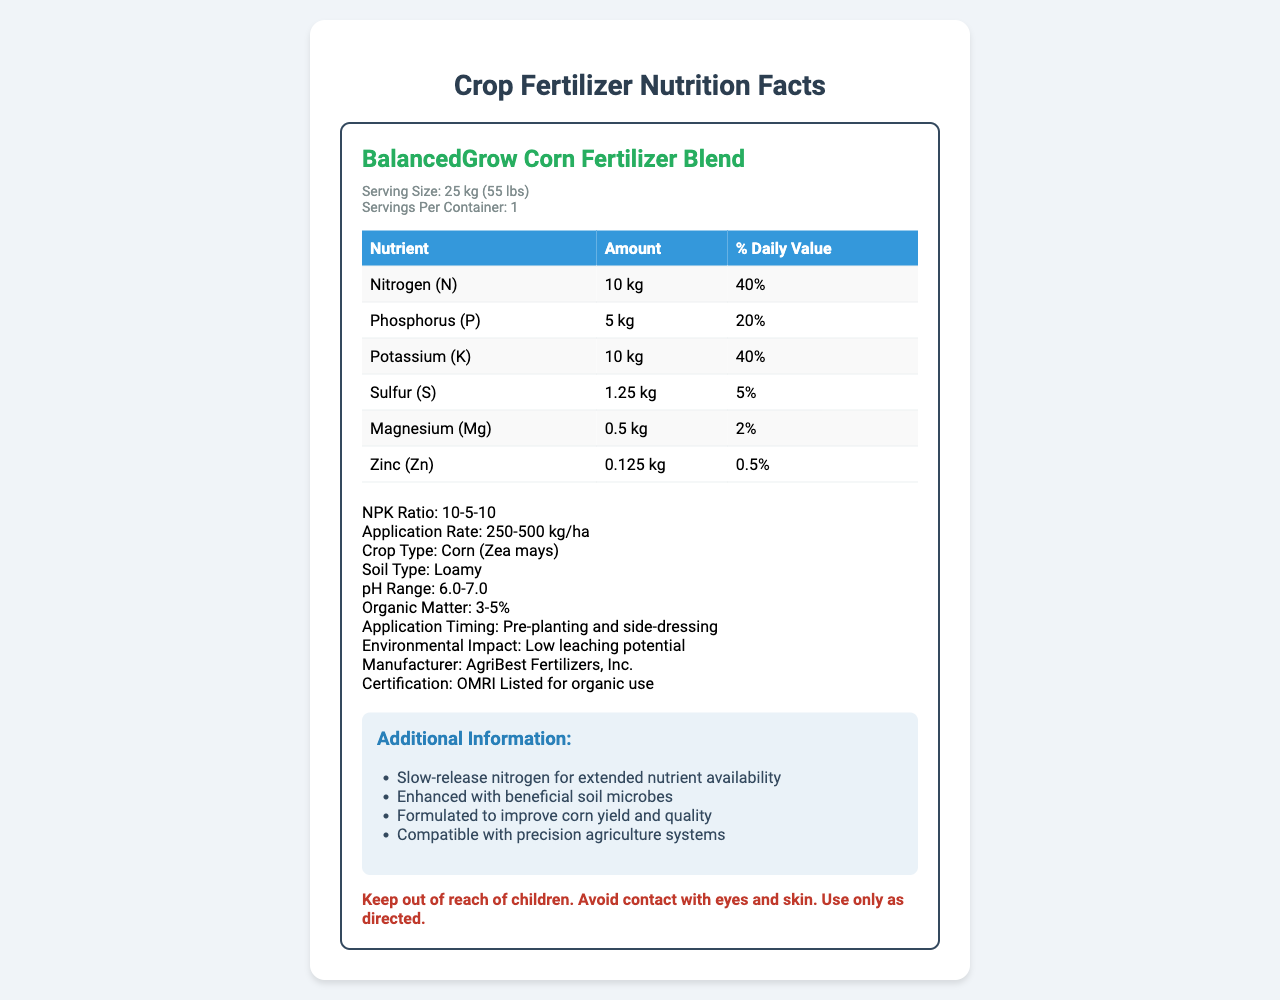what is the NPK ratio of the BalancedGrow Corn Fertilizer Blend? The document clearly states the NPK ratio as "10-5-10."
Answer: 10-5-10 what is the recommended application rate? The document specifies that the application rate is "250-500 kg/ha."
Answer: 250-500 kg/ha what soil type is this fertilizer blend best suited for? The document mentions that the suitable soil type is "Loamy."
Answer: Loamy how much Phosphorus (P) does one serving contain? The table lists the amount of Phosphorus as "5 kg."
Answer: 5 kg what is the percentage daily value of Sulfur (S) provided by this fertilizer? According to the table, Sulfur has a daily value percentage of "5%."
Answer: 5% what nutrient has the lowest percentage daily value in this fertilizer blend? A. Nitrogen (N) B. Phosphorus (P) C. Magnesium (Mg) D. Zinc (Zn) The table shows Zinc (Zn) with a percentage daily value of "0.5%", which is the lowest among the listed nutrients.
Answer: D. Zinc (Zn) who is the manufacturer of this fertilizer? A. AgriBest Fertilizers, Inc. B. GreenGrow Fertilizers Co. C. CropCare Manufacturers The document states that the manufacturer is "AgriBest Fertilizers, Inc."
Answer: A. AgriBest Fertilizers, Inc. can this fertilizer be used in organic farming? The document mentions that the fertilizer is "OMRI Listed for organic use."
Answer: Yes describe the main purpose and key details of this document. The document serves as a comprehensive guide to the BalancedGrow Corn Fertilizer Blend, highlighting its nutrient composition, recommended usage, and additional benefits to help users make informed decisions.
Answer: The document provides detailed nutrition facts about the BalancedGrow Corn Fertilizer Blend. It includes information on serving size, NPK ratio, nutrient content, application rates, recommended soil type, and other beneficial attributes. The product is intended to optimize corn yield and quality through its balanced nutrient profile and additional features like slow-release nitrogen and beneficial soil microbes. what is the recommended pH range for soils using this fertilizer blend? The document provides the recommended pH range as "6.0-7.0."
Answer: 6.0-7.0 how much Magnesium (Mg) is in the fertilizer per serving? According to the nutrient content table, the amount of Magnesium is "0.5 kg."
Answer: 0.5 kg is the fertilizer suitable for precision agriculture systems? The document states that the fertilizer is "Compatible with precision agriculture systems."
Answer: Yes when should this fertilizer be applied for best results? The document mentions that the application timing should be "Pre-planting and side-dressing."
Answer: Pre-planting and side-dressing does the label provide the exact cost of the fertilizer? The document does not specify the cost of the fertilizer.
Answer: Not enough information what is one additional feature of this fertilizer that extends nutrient availability? The document states that the fertilizer includes "Slow-release nitrogen for extended nutrient availability."
Answer: Slow-release nitrogen how many servings are there per container of this fertilizer? The document indicates that there is "1" serving per container.
Answer: 1 